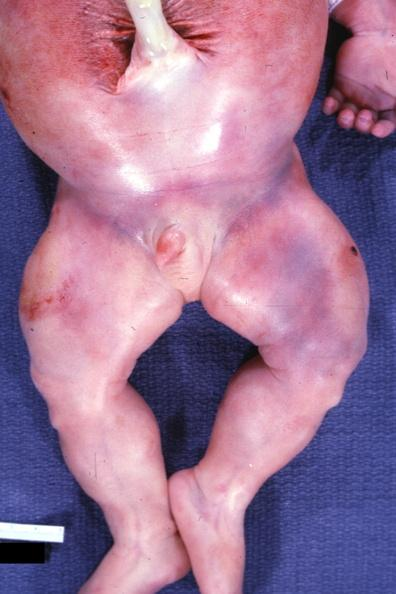how does this image show lower extremities?
Answer the question using a single word or phrase. With increased muscle mass several other slides 